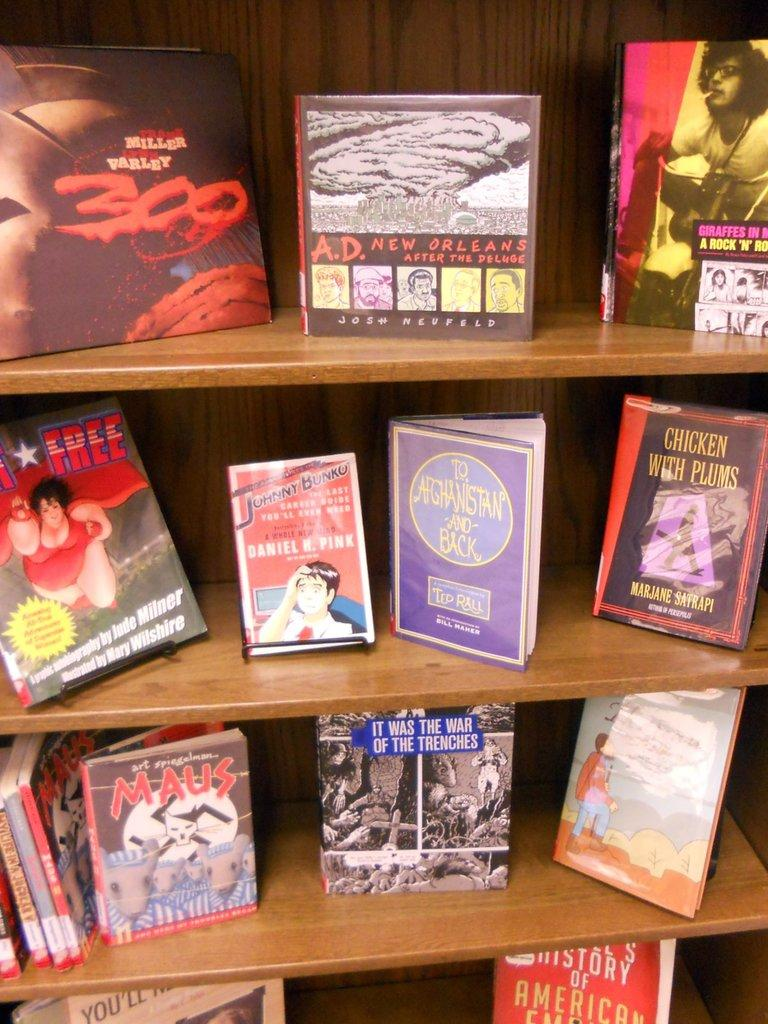<image>
Render a clear and concise summary of the photo. Chicken with Plums is one of the books on shelves with many. 